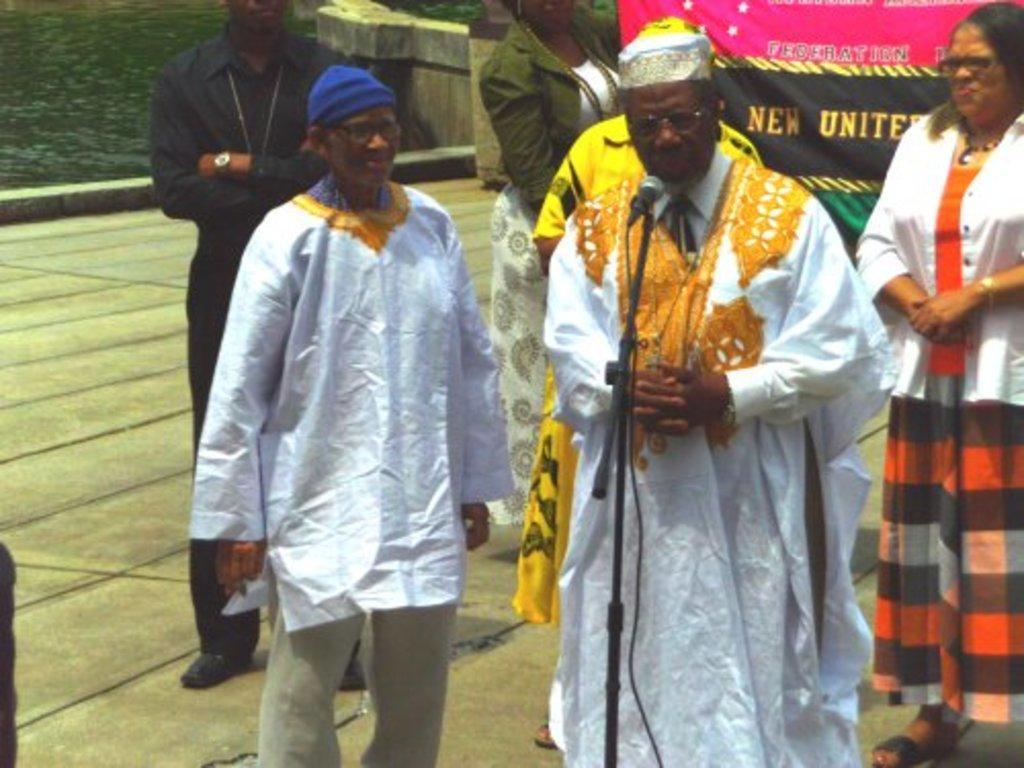Could you give a brief overview of what you see in this image? In this image there are a few people standing. In the center there is a microphone to its stand. Behind them there is a banner with the text. In the top left there is the water. 